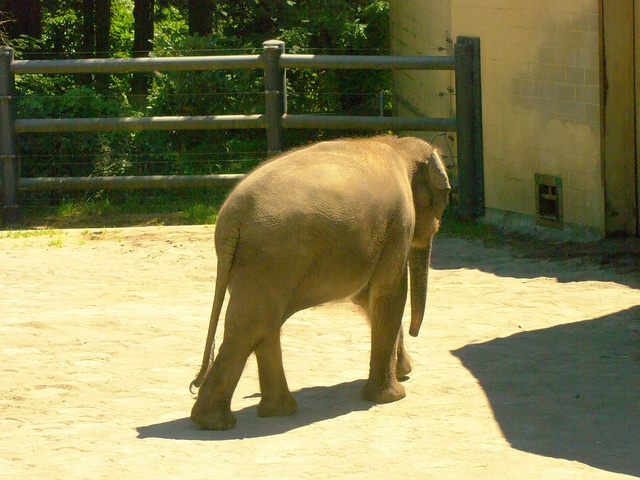Describe the objects in this image and their specific colors. I can see a elephant in black, olive, tan, and maroon tones in this image. 